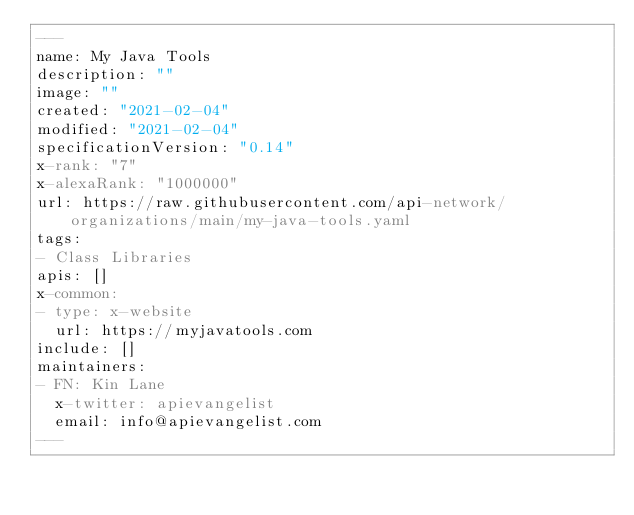Convert code to text. <code><loc_0><loc_0><loc_500><loc_500><_YAML_>---
name: My Java Tools
description: ""
image: ""
created: "2021-02-04"
modified: "2021-02-04"
specificationVersion: "0.14"
x-rank: "7"
x-alexaRank: "1000000"
url: https://raw.githubusercontent.com/api-network/organizations/main/my-java-tools.yaml
tags:
- Class Libraries
apis: []
x-common:
- type: x-website
  url: https://myjavatools.com
include: []
maintainers:
- FN: Kin Lane
  x-twitter: apievangelist
  email: info@apievangelist.com
---</code> 